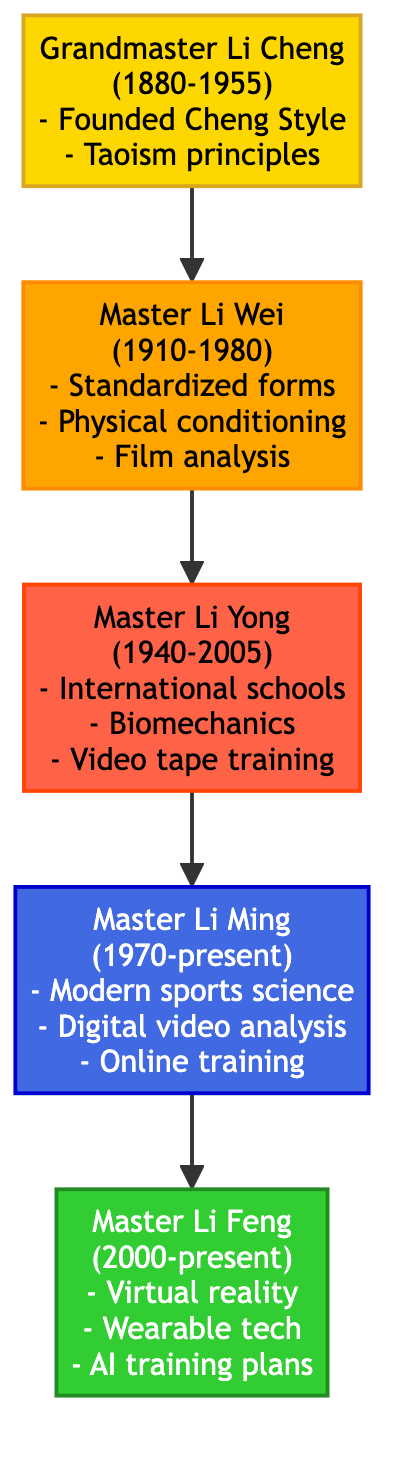What is the birth year of Grandmaster Li Cheng? The diagram provides the birth year of Grandmaster Li Cheng, which is explicitly stated as 1880.
Answer: 1880 How many generations of masters are represented in the diagram? The diagram includes five nodes representing the generations: one ancestor and four successive masters, totaling five generations.
Answer: 5 Who contributed to the incorporation of biomechanics into training methods? By examining the contributions listed under each master, it is clear that Master Li Yong, from the 3rd generation, specifically mentioned incorporating biomechanics into training methods.
Answer: Master Li Yong What significant technological advance did Master Li Feng adopt? Looking at the contributions under Master Li Feng, it is evident that he integrated virtual reality for immersive training experiences, marking a significant technological advance.
Answer: Virtual reality What is the relationship between Master Li Wei and Grandmaster Li Cheng? According to the structure of the family tree, Master Li Wei is the second generation and is directly connected as the child of Grandmaster Li Cheng, who is the ancestor.
Answer: Father Which master was the first to use film for training analysis? The diagram shows that Master Li Wei was the first to adopt film as a method for analyzing and teaching techniques, as mentioned in his contributions.
Answer: Master Li Wei What common theme do all masters' contributions share regarding training methods? Analyzing the contributions across all masters reveals a progression towards enhanced training methods, with each generation adopting newer technologies or principles to improve martial arts training.
Answer: Enhanced training methods Which contribution was made by Master Li Ming regarding training technology? By reviewing the contributions under Master Li Ming, it is identified that he utilized digital video analysis software for technique improvement as part of his contributions to training technology.
Answer: Digital video analysis software What year did Master Li Yong pass away? The diagram lists the death year of Master Li Yong as 2005, providing a clear answer to this inquiry.
Answer: 2005 How does Master Li Feng's technology differ from those of earlier generations? Observing the lineage, Master Li Feng stands out for adopting advanced technologies like virtual reality and artificial intelligence, whereas earlier masters focused on more traditional methods and film techniques.
Answer: Advanced technologies 